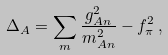<formula> <loc_0><loc_0><loc_500><loc_500>\Delta _ { A } = \sum _ { m } \frac { g _ { A n } ^ { 2 } } { m _ { A n } ^ { 2 } } - f _ { \pi } ^ { 2 } \, ,</formula> 